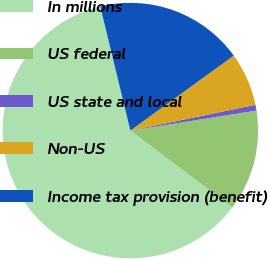<chart> <loc_0><loc_0><loc_500><loc_500><pie_chart><fcel>In millions<fcel>US federal<fcel>US state and local<fcel>Non-US<fcel>Income tax provision (benefit)<nl><fcel>60.95%<fcel>12.77%<fcel>0.73%<fcel>6.75%<fcel>18.8%<nl></chart> 